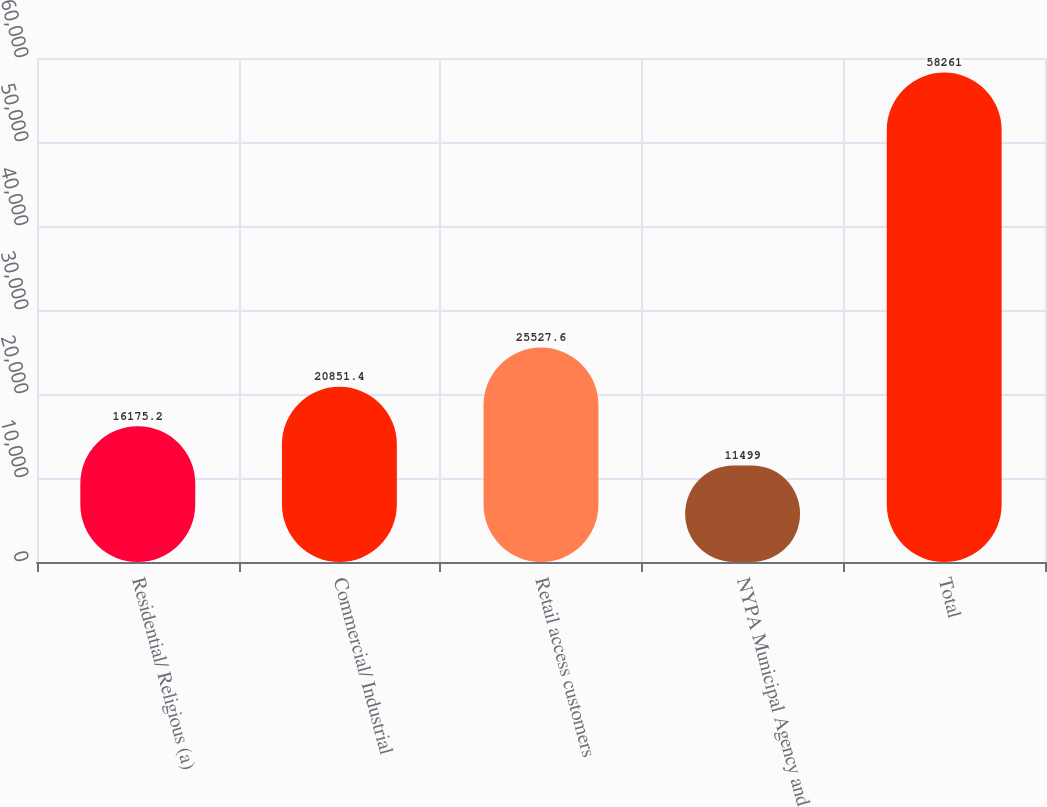Convert chart. <chart><loc_0><loc_0><loc_500><loc_500><bar_chart><fcel>Residential/ Religious (a)<fcel>Commercial/ Industrial<fcel>Retail access customers<fcel>NYPA Municipal Agency and<fcel>Total<nl><fcel>16175.2<fcel>20851.4<fcel>25527.6<fcel>11499<fcel>58261<nl></chart> 